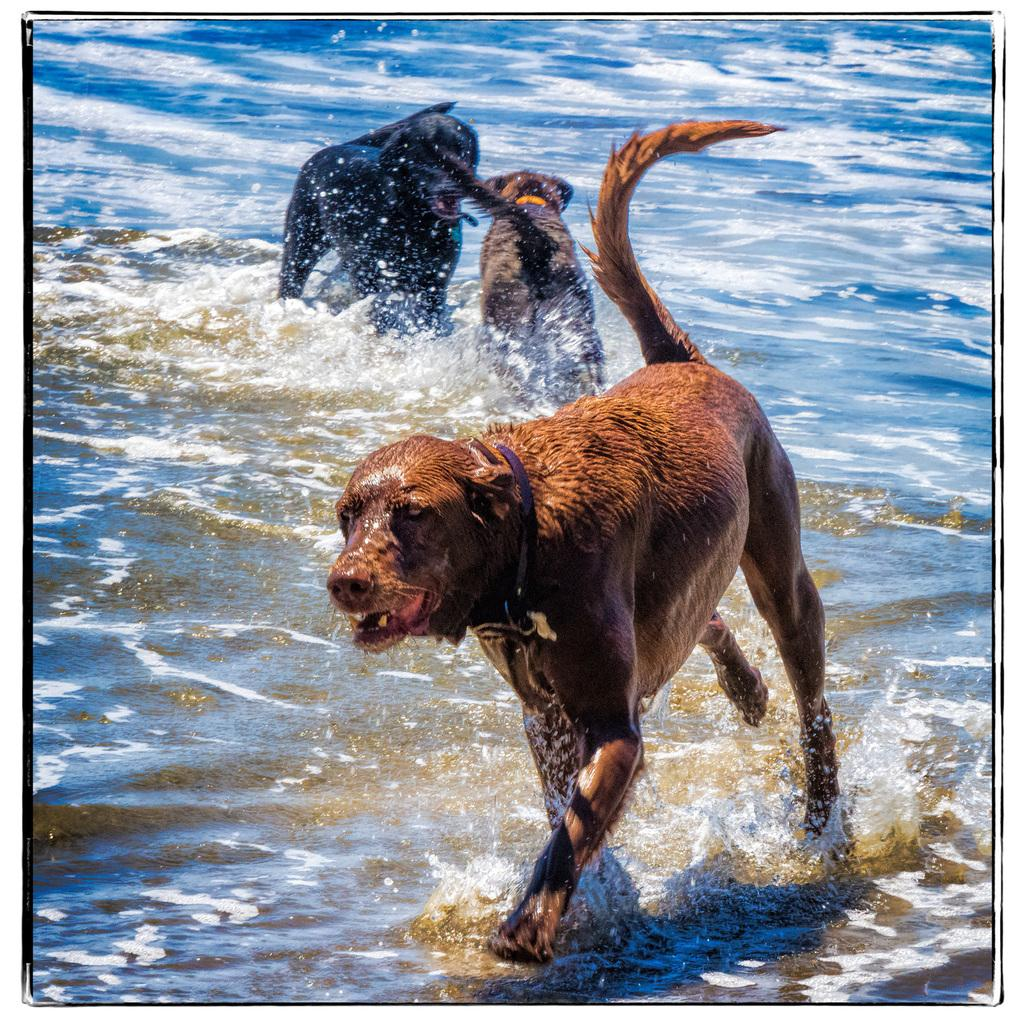How many dogs are present in the image? There are three dogs in the image. What is the location of the dogs in the image? The dogs are in the water. What type of beverage is the dogs drinking in the image? There is no beverage present in the image; the dogs are in the water. What is the dogs' emotional state in the image? The provided facts do not give information about the dogs' emotional state. 